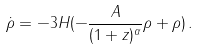Convert formula to latex. <formula><loc_0><loc_0><loc_500><loc_500>\dot { \rho } = - 3 H ( - \frac { A } { ( 1 + z ) ^ { \alpha } } \rho + \rho ) \, .</formula> 